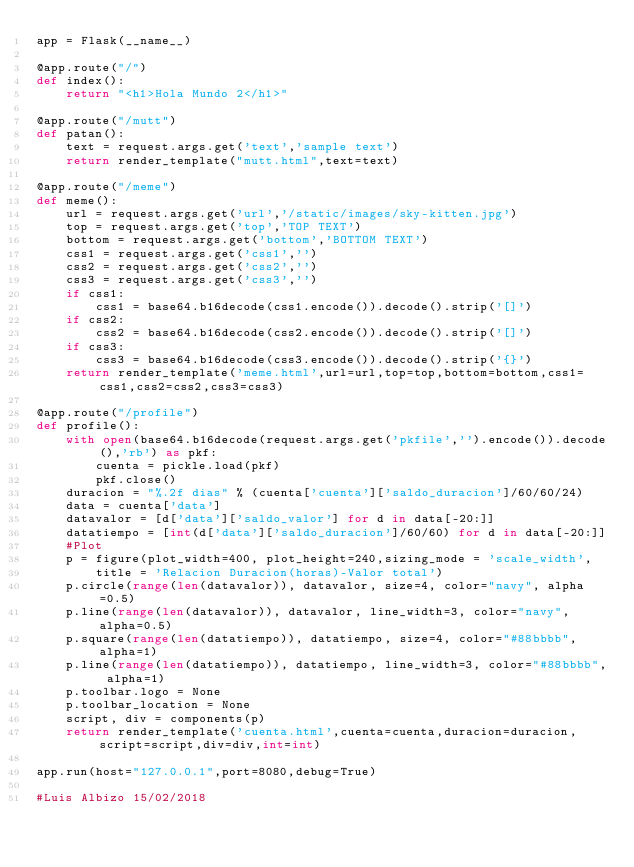<code> <loc_0><loc_0><loc_500><loc_500><_Python_>app = Flask(__name__)

@app.route("/")
def index():
    return "<h1>Hola Mundo 2</h1>"

@app.route("/mutt")
def patan():
    text = request.args.get('text','sample text')
    return render_template("mutt.html",text=text)

@app.route("/meme")
def meme():
    url = request.args.get('url','/static/images/sky-kitten.jpg')
    top = request.args.get('top','TOP TEXT')
    bottom = request.args.get('bottom','BOTTOM TEXT')
    css1 = request.args.get('css1','')
    css2 = request.args.get('css2','')
    css3 = request.args.get('css3','')
    if css1:
        css1 = base64.b16decode(css1.encode()).decode().strip('[]')
    if css2:
        css2 = base64.b16decode(css2.encode()).decode().strip('[]')
    if css3:
        css3 = base64.b16decode(css3.encode()).decode().strip('{}')
    return render_template('meme.html',url=url,top=top,bottom=bottom,css1=css1,css2=css2,css3=css3)

@app.route("/profile")
def profile():
    with open(base64.b16decode(request.args.get('pkfile','').encode()).decode(),'rb') as pkf:
        cuenta = pickle.load(pkf)
        pkf.close()
    duracion = "%.2f dias" % (cuenta['cuenta']['saldo_duracion']/60/60/24)
    data = cuenta['data']
    datavalor = [d['data']['saldo_valor'] for d in data[-20:]]
    datatiempo = [int(d['data']['saldo_duracion']/60/60) for d in data[-20:]]
    #Plot
    p = figure(plot_width=400, plot_height=240,sizing_mode = 'scale_width',
        title = 'Relacion Duracion(horas)-Valor total')
    p.circle(range(len(datavalor)), datavalor, size=4, color="navy", alpha=0.5)
    p.line(range(len(datavalor)), datavalor, line_width=3, color="navy", alpha=0.5)
    p.square(range(len(datatiempo)), datatiempo, size=4, color="#88bbbb", alpha=1)
    p.line(range(len(datatiempo)), datatiempo, line_width=3, color="#88bbbb", alpha=1)
    p.toolbar.logo = None
    p.toolbar_location = None
    script, div = components(p)
    return render_template('cuenta.html',cuenta=cuenta,duracion=duracion,script=script,div=div,int=int)

app.run(host="127.0.0.1",port=8080,debug=True)

#Luis Albizo 15/02/2018
</code> 